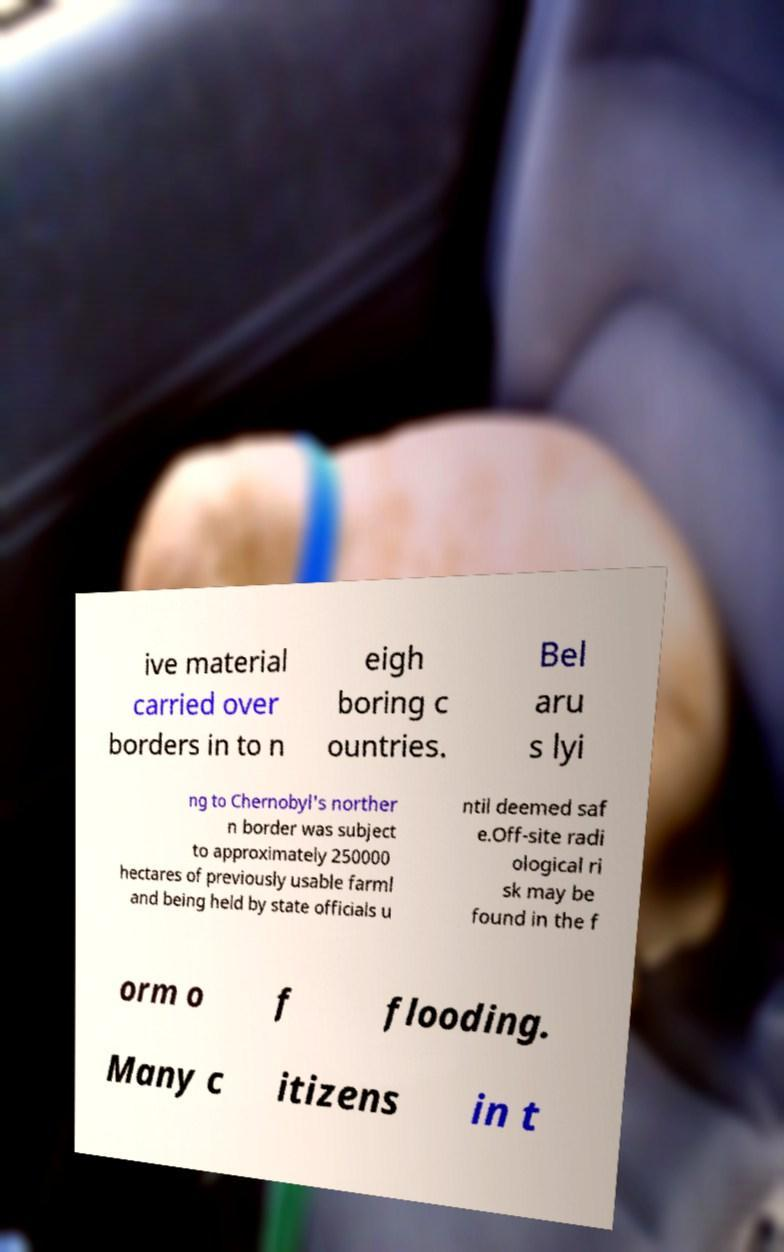Please identify and transcribe the text found in this image. ive material carried over borders in to n eigh boring c ountries. Bel aru s lyi ng to Chernobyl's norther n border was subject to approximately 250000 hectares of previously usable farml and being held by state officials u ntil deemed saf e.Off-site radi ological ri sk may be found in the f orm o f flooding. Many c itizens in t 